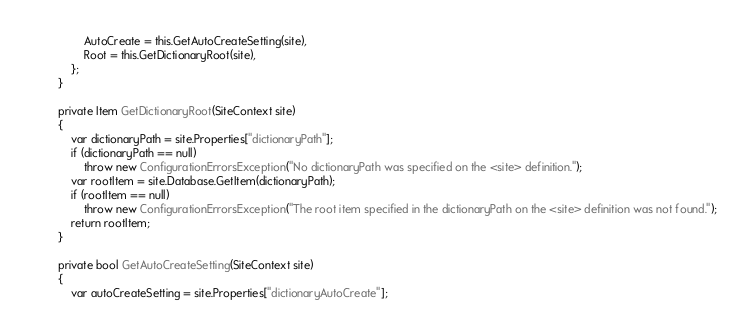Convert code to text. <code><loc_0><loc_0><loc_500><loc_500><_C#_>                AutoCreate = this.GetAutoCreateSetting(site),
                Root = this.GetDictionaryRoot(site),
            };
        }

        private Item GetDictionaryRoot(SiteContext site)
        {
            var dictionaryPath = site.Properties["dictionaryPath"];
            if (dictionaryPath == null)
                throw new ConfigurationErrorsException("No dictionaryPath was specified on the <site> definition.");
            var rootItem = site.Database.GetItem(dictionaryPath);
            if (rootItem == null)
                throw new ConfigurationErrorsException("The root item specified in the dictionaryPath on the <site> definition was not found.");
            return rootItem;
        }

        private bool GetAutoCreateSetting(SiteContext site)
        {
            var autoCreateSetting = site.Properties["dictionaryAutoCreate"];</code> 